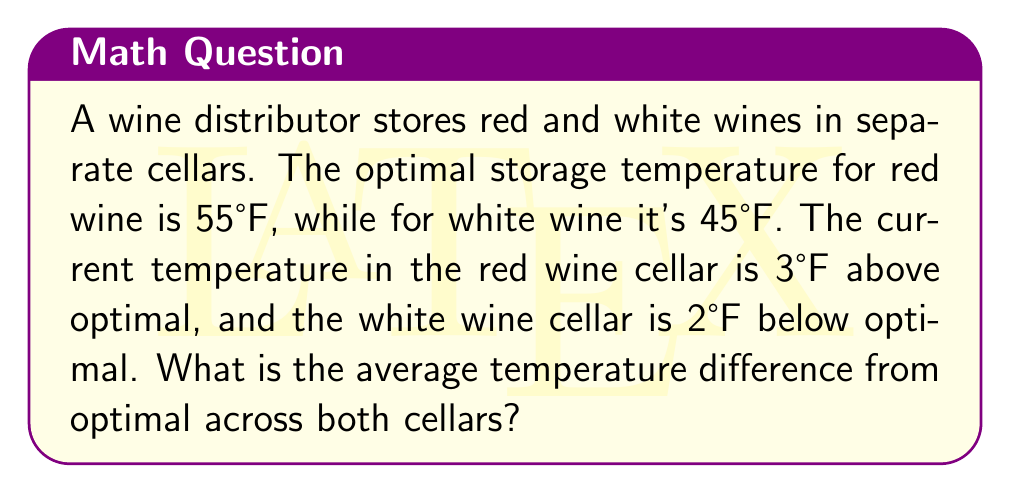Could you help me with this problem? Let's solve this problem step by step:

1) First, let's identify the given information:
   - Optimal temperature for red wine: 55°F
   - Optimal temperature for white wine: 45°F
   - Red wine cellar: 3°F above optimal
   - White wine cellar: 2°F below optimal

2) Calculate the actual temperature in the red wine cellar:
   $$ \text{Red cellar temp} = 55°F + 3°F = 58°F $$

3) Calculate the actual temperature in the white wine cellar:
   $$ \text{White cellar temp} = 45°F - 2°F = 43°F $$

4) Calculate the temperature difference from optimal for each cellar:
   - Red wine cellar: $58°F - 55°F = 3°F$ above optimal
   - White wine cellar: $45°F - 43°F = 2°F$ below optimal

5) To find the average temperature difference, we add the absolute values of these differences and divide by 2:
   $$ \text{Average difference} = \frac{|3°F| + |2°F|}{2} = \frac{5°F}{2} = 2.5°F $$
Answer: 2.5°F 